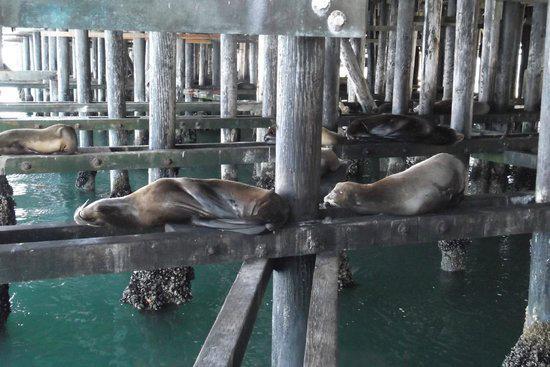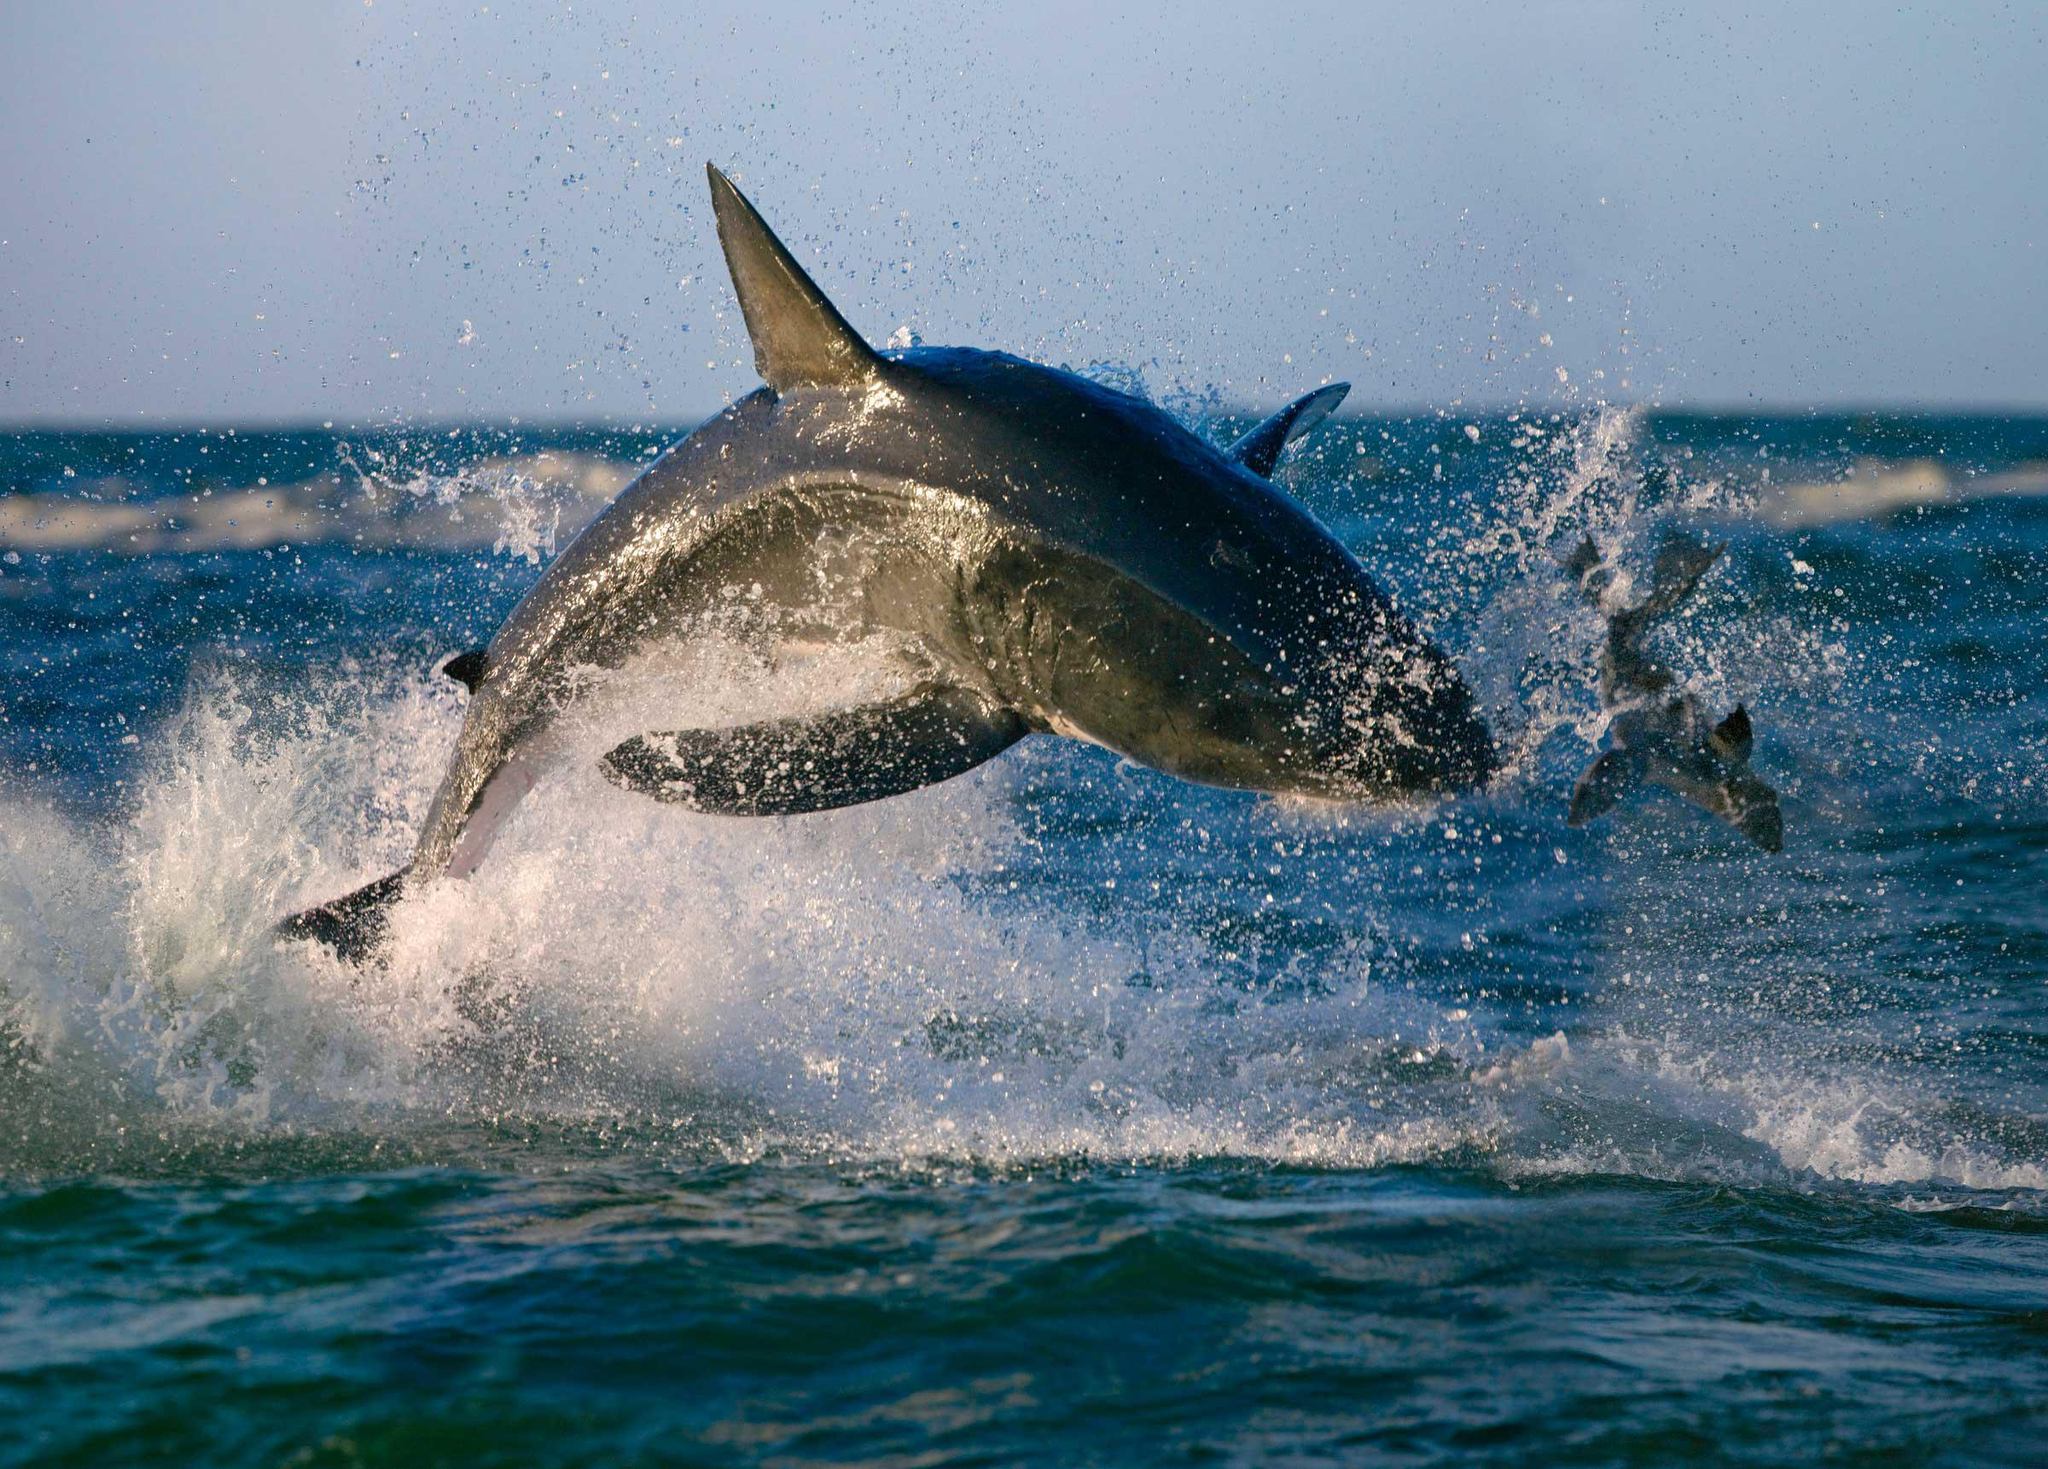The first image is the image on the left, the second image is the image on the right. Considering the images on both sides, is "The left image shows at least one seal balanced on a cross beam near vertical poles in water beneath a pier." valid? Answer yes or no. Yes. The first image is the image on the left, the second image is the image on the right. Evaluate the accuracy of this statement regarding the images: "There are sea lions resting on the narrow beams under the pier.". Is it true? Answer yes or no. Yes. 